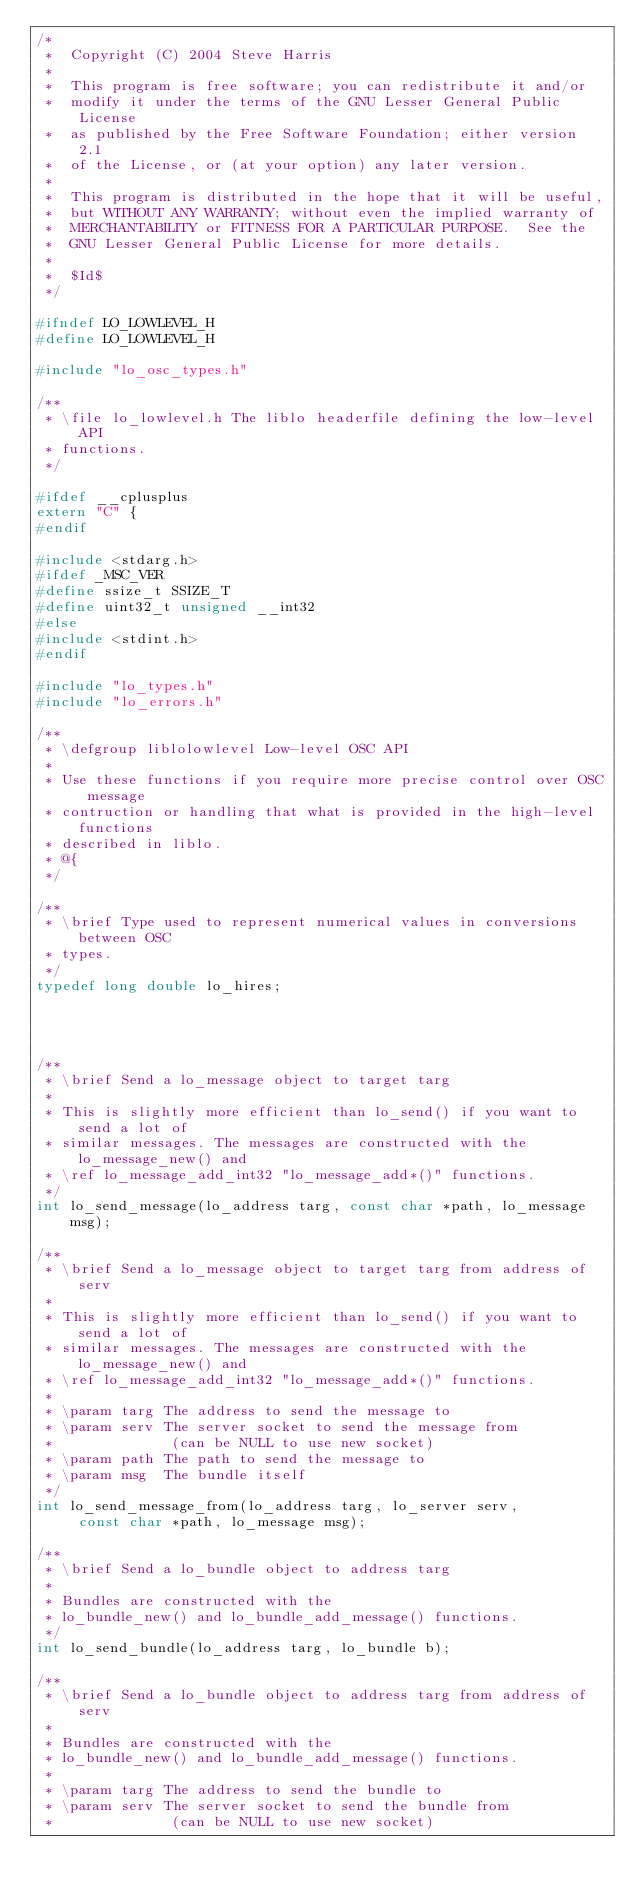<code> <loc_0><loc_0><loc_500><loc_500><_C_>/*
 *  Copyright (C) 2004 Steve Harris
 *
 *  This program is free software; you can redistribute it and/or
 *  modify it under the terms of the GNU Lesser General Public License
 *  as published by the Free Software Foundation; either version 2.1
 *  of the License, or (at your option) any later version.
 *
 *  This program is distributed in the hope that it will be useful,
 *  but WITHOUT ANY WARRANTY; without even the implied warranty of
 *  MERCHANTABILITY or FITNESS FOR A PARTICULAR PURPOSE.  See the
 *  GNU Lesser General Public License for more details.
 *
 *  $Id$
 */

#ifndef LO_LOWLEVEL_H
#define LO_LOWLEVEL_H

#include "lo_osc_types.h"

/**
 * \file lo_lowlevel.h The liblo headerfile defining the low-level API
 * functions.
 */

#ifdef __cplusplus
extern "C" {
#endif

#include <stdarg.h>
#ifdef _MSC_VER
#define ssize_t SSIZE_T
#define uint32_t unsigned __int32
#else
#include <stdint.h>
#endif

#include "lo_types.h"
#include "lo_errors.h"

/**
 * \defgroup liblolowlevel Low-level OSC API
 *
 * Use these functions if you require more precise control over OSC message
 * contruction or handling that what is provided in the high-level functions
 * described in liblo.
 * @{
 */

/**
 * \brief Type used to represent numerical values in conversions between OSC
 * types.
 */
typedef long double lo_hires;




/**
 * \brief Send a lo_message object to target targ
 *
 * This is slightly more efficient than lo_send() if you want to send a lot of
 * similar messages. The messages are constructed with the lo_message_new() and
 * \ref lo_message_add_int32 "lo_message_add*()" functions.
 */
int lo_send_message(lo_address targ, const char *path, lo_message msg);

/**
 * \brief Send a lo_message object to target targ from address of serv
 *
 * This is slightly more efficient than lo_send() if you want to send a lot of
 * similar messages. The messages are constructed with the lo_message_new() and
 * \ref lo_message_add_int32 "lo_message_add*()" functions.
 *
 * \param targ The address to send the message to
 * \param serv The server socket to send the message from
 *              (can be NULL to use new socket)
 * \param path The path to send the message to
 * \param msg  The bundle itself
 */
int lo_send_message_from(lo_address targ, lo_server serv, 
     const char *path, lo_message msg);

/**
 * \brief Send a lo_bundle object to address targ
 *
 * Bundles are constructed with the
 * lo_bundle_new() and lo_bundle_add_message() functions.
 */
int lo_send_bundle(lo_address targ, lo_bundle b);

/**
 * \brief Send a lo_bundle object to address targ from address of serv
 *
 * Bundles are constructed with the
 * lo_bundle_new() and lo_bundle_add_message() functions.
 *
 * \param targ The address to send the bundle to
 * \param serv The server socket to send the bundle from 
 *              (can be NULL to use new socket)</code> 